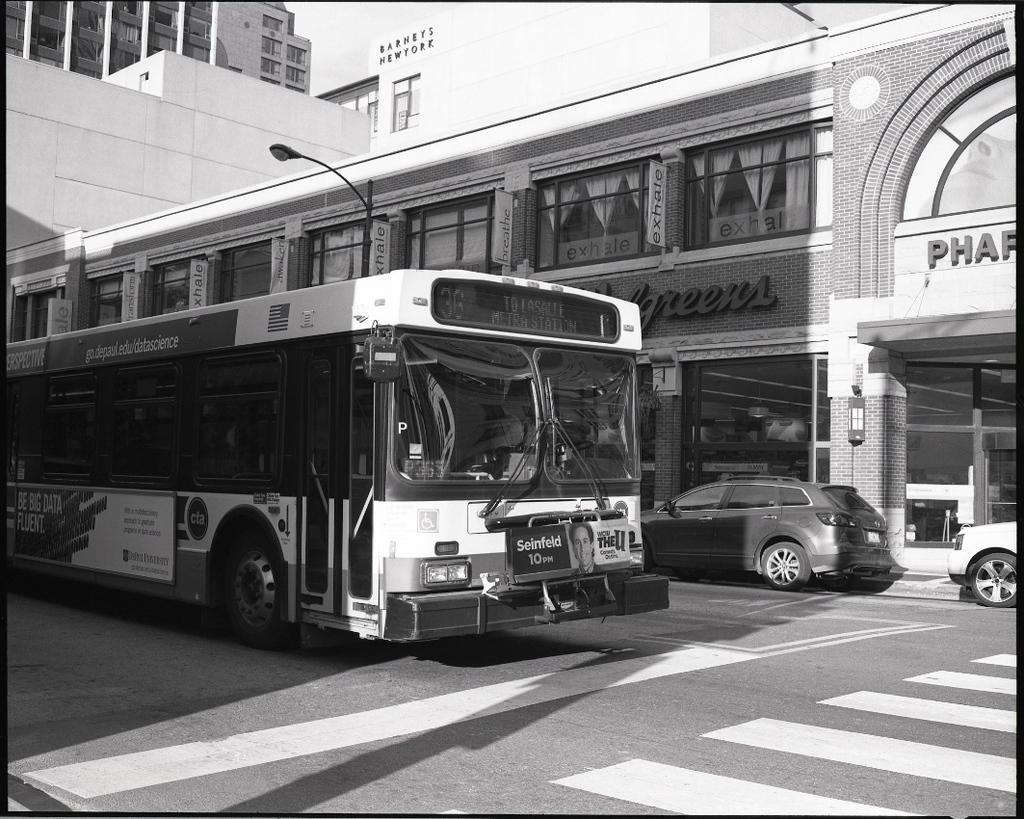Describe this image in one or two sentences. In this image we can see a bus and cars on the road. In the background there are buildings and a pole. 